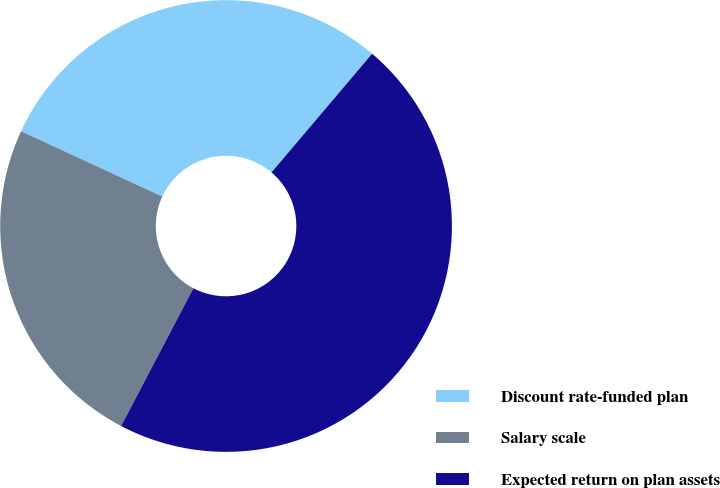<chart> <loc_0><loc_0><loc_500><loc_500><pie_chart><fcel>Discount rate-funded plan<fcel>Salary scale<fcel>Expected return on plan assets<nl><fcel>29.3%<fcel>24.2%<fcel>46.5%<nl></chart> 